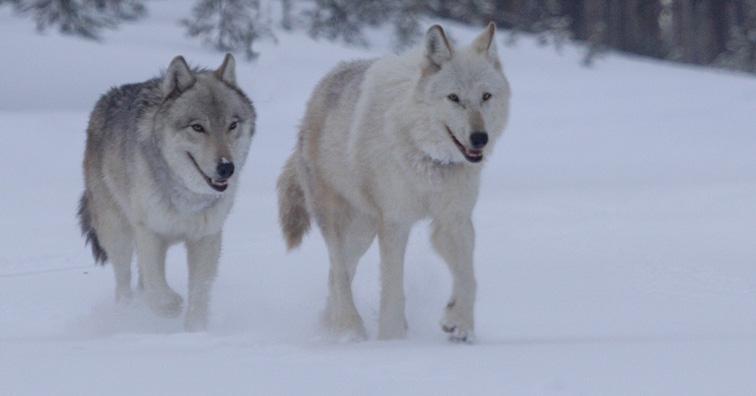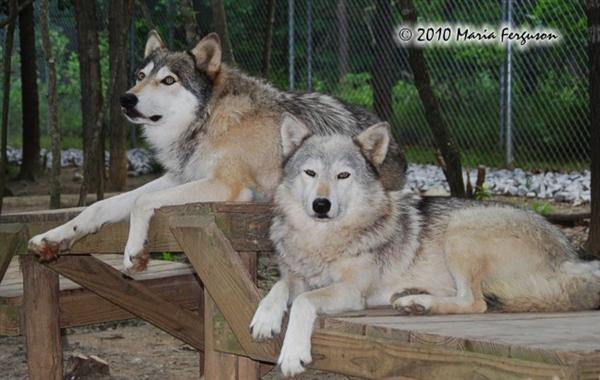The first image is the image on the left, the second image is the image on the right. Given the left and right images, does the statement "The combined images contain four wolves, including two adult wolves sitting upright with heads lifted, eyes shut, and mouths open in a howling pose." hold true? Answer yes or no. No. The first image is the image on the left, the second image is the image on the right. For the images displayed, is the sentence "There are two wolves in each image." factually correct? Answer yes or no. Yes. 